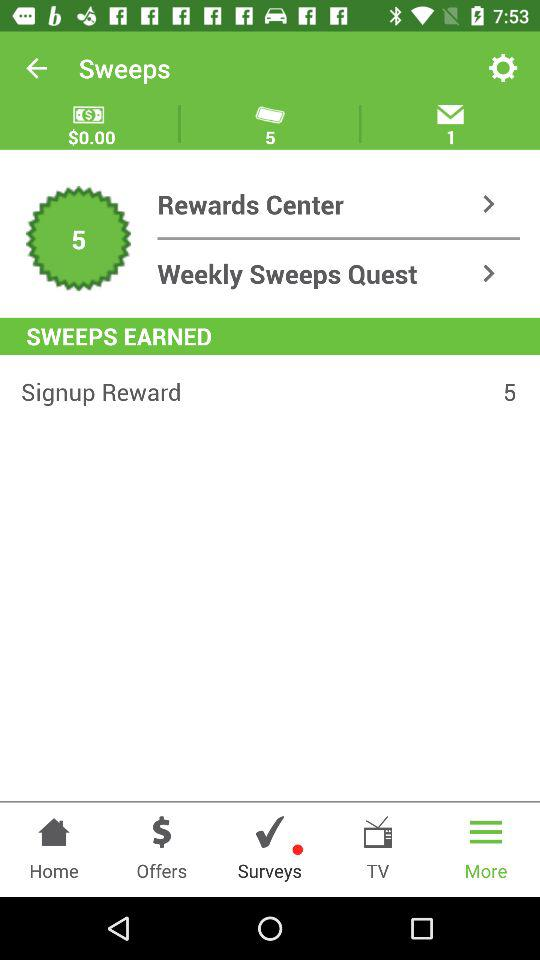What is the amount in dollars? The amount in dollars is 0. 